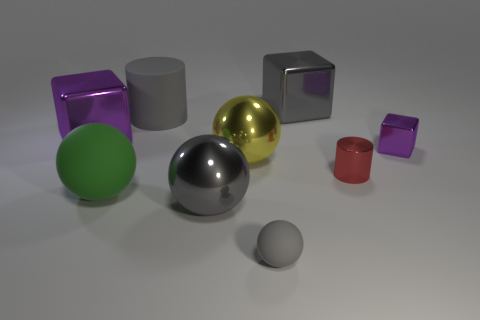Is the yellow ball made of the same material as the large green thing? no 